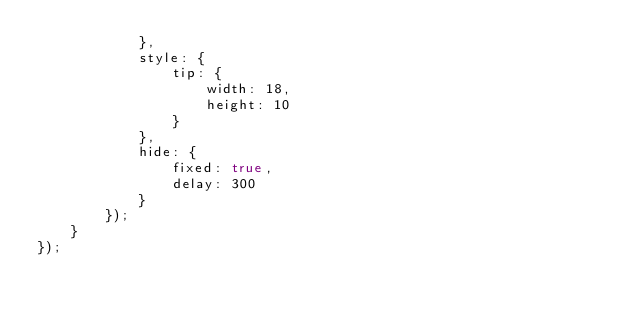Convert code to text. <code><loc_0><loc_0><loc_500><loc_500><_JavaScript_>            },
            style: {
                tip: {
                    width: 18,
                    height: 10
                }
            },
            hide: {
                fixed: true,
                delay: 300
            }
        });
    }
});
</code> 